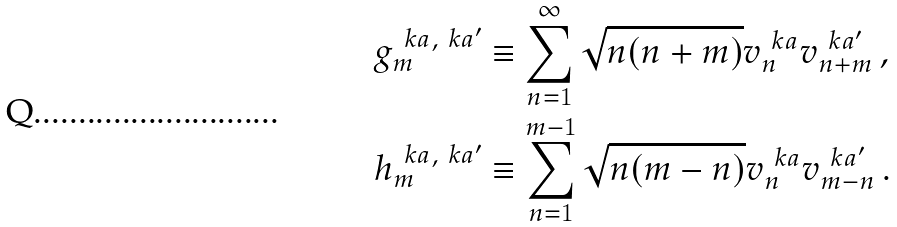<formula> <loc_0><loc_0><loc_500><loc_500>g ^ { \ k a , \ k a ^ { \prime } } _ { m } & \equiv \sum _ { n = 1 } ^ { \infty } \sqrt { n ( n + m ) } v _ { n } ^ { \ k a } v _ { n + m } ^ { \ k a ^ { \prime } } \, , \\ h ^ { \ k a , \ k a ^ { \prime } } _ { m } & \equiv \sum _ { n = 1 } ^ { m - 1 } \sqrt { n ( m - n ) } v _ { n } ^ { \ k a } v _ { m - n } ^ { \ k a ^ { \prime } } \, .</formula> 